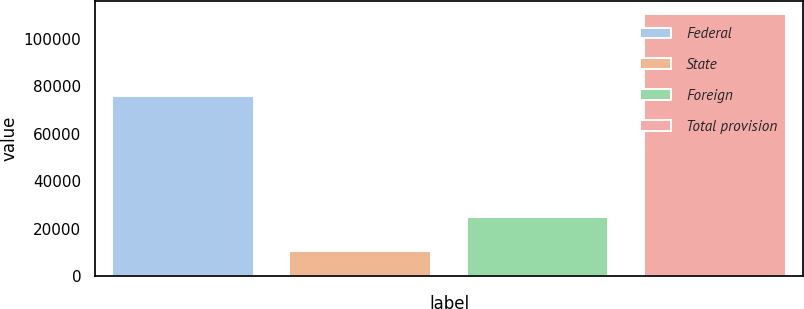Convert chart. <chart><loc_0><loc_0><loc_500><loc_500><bar_chart><fcel>Federal<fcel>State<fcel>Foreign<fcel>Total provision<nl><fcel>75698<fcel>10621<fcel>24931<fcel>110180<nl></chart> 